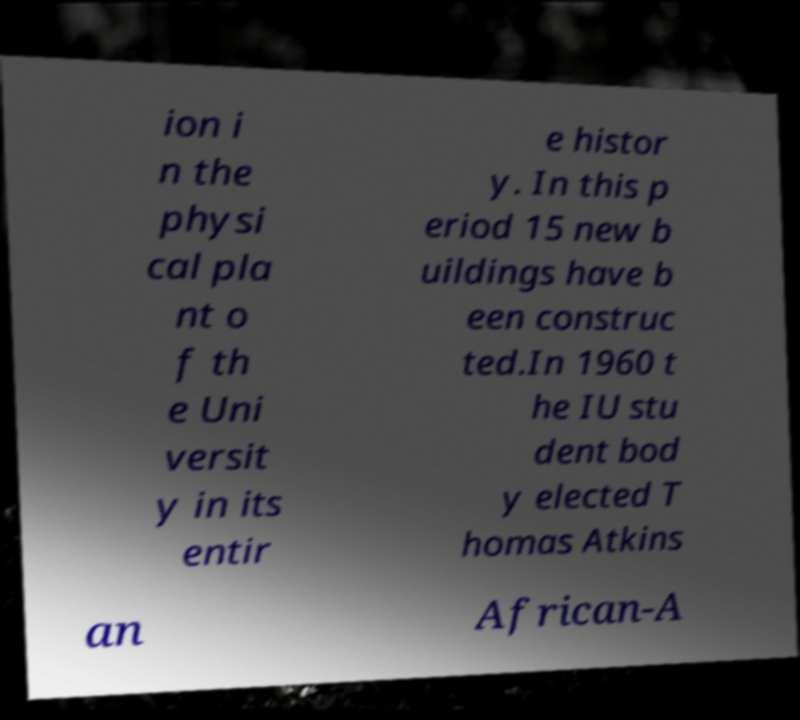Please identify and transcribe the text found in this image. ion i n the physi cal pla nt o f th e Uni versit y in its entir e histor y. In this p eriod 15 new b uildings have b een construc ted.In 1960 t he IU stu dent bod y elected T homas Atkins an African-A 